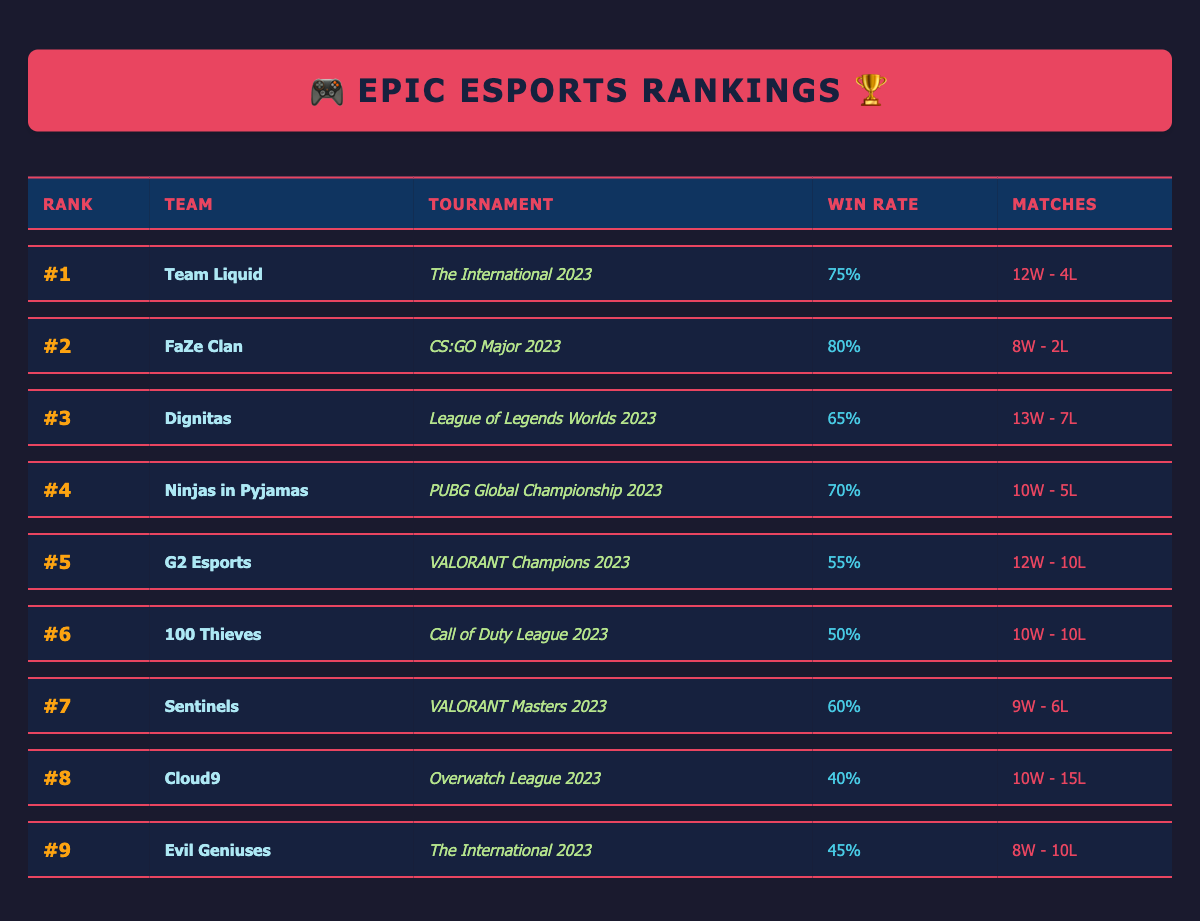What's the win rate of Team Liquid at The International 2023? Team Liquid's win rate is listed in the table under The International 2023, which shows 75%.
Answer: 75% Which team has the highest win rate in the table? By looking at each win rate in the table, FaZe Clan has the highest win rate of 80% at the CS:GO Major 2023.
Answer: FaZe Clan (80%) How many matches did G2 Esports play at VALORANT Champions 2023? The table indicates that G2 Esports played a total of 22 matches during the VALORANT Champions 2023 tournament.
Answer: 22 matches Is the win rate of 100 Thieves higher than that of Evil Geniuses? 100 Thieves has a win rate of 50%, while Evil Geniuses has a win rate of 45%. Since 50% is greater than 45%, the statement is true.
Answer: Yes What is the total number of matches played by Team Liquid and FaZe Clan combined? Team Liquid played 16 matches and FaZe Clan played 10 matches. Adding these together gives 16 + 10 = 26 matches.
Answer: 26 matches How many teams have a win rate lower than 50%? Analyzing the win rates in the table, only Cloud9 (40%) fits this criterion, so there is 1 team with a win rate below 50%.
Answer: 1 team What is the average win rate of all teams listed? The win rates are 75%, 80%, 65%, 70%, 55%, 50%, 60%, 40%, and 45%. Summing these gives 75 + 80 + 65 + 70 + 55 + 50 + 60 + 40 + 45 = 500. Dividing by 9 teams gives an average of 500 / 9 = approximately 55.56%.
Answer: 55.56% Which team ranked 6th had a 50% win rate? The table shows that 100 Thieves is ranked 6th with a win rate of 50%.
Answer: 100 Thieves What’s the difference in matches won between Dignitas and Ninjas in Pyjamas? Dignitas won 13 matches, and Ninjas in Pyjamas won 10 matches. The difference is 13 - 10 = 3 matches.
Answer: 3 matches Which tournament had the lowest win rate for the participating teams? Looking at the win rates, Cloud9 has the lowest at 40% in the Overwatch League 2023.
Answer: Overwatch League 2023 